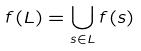<formula> <loc_0><loc_0><loc_500><loc_500>f ( L ) = \bigcup _ { s \in L } f ( s )</formula> 